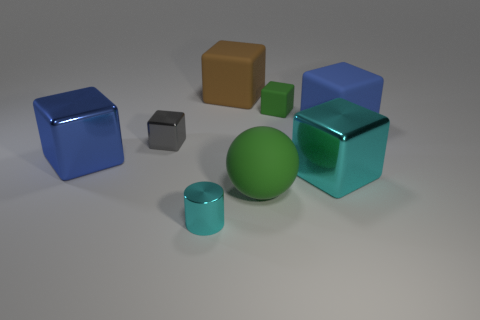Subtract 2 cubes. How many cubes are left? 4 Subtract all blue cubes. How many cubes are left? 4 Subtract all small metal blocks. How many blocks are left? 5 Subtract all yellow cubes. Subtract all gray spheres. How many cubes are left? 6 Add 1 tiny blue rubber things. How many objects exist? 9 Subtract all cylinders. How many objects are left? 7 Add 1 cyan metal objects. How many cyan metal objects exist? 3 Subtract 0 cyan balls. How many objects are left? 8 Subtract all big cyan metal things. Subtract all metallic cylinders. How many objects are left? 6 Add 3 green objects. How many green objects are left? 5 